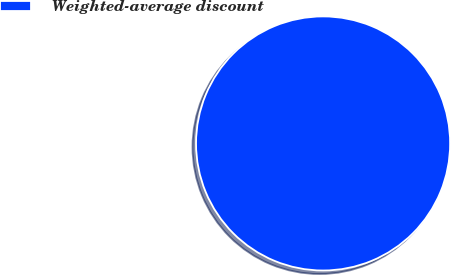Convert chart to OTSL. <chart><loc_0><loc_0><loc_500><loc_500><pie_chart><fcel>Weighted-average discount<nl><fcel>100.0%<nl></chart> 